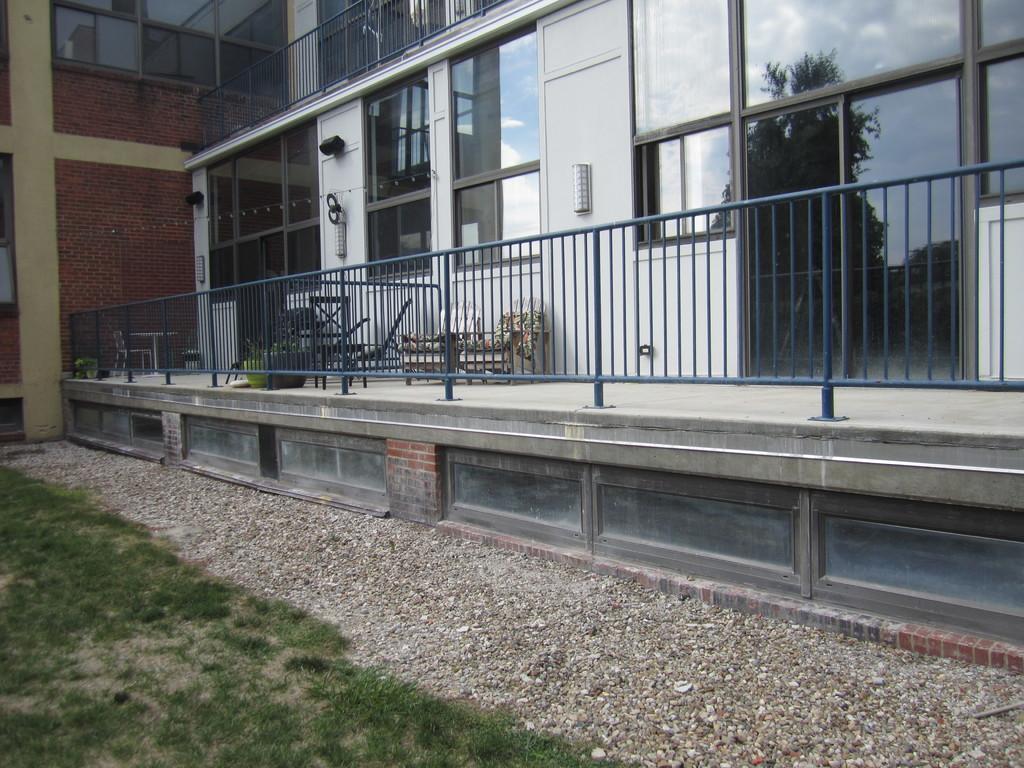How would you summarize this image in a sentence or two? There are small pebbles and grassland in the foreground area of the image, there is a building and chairs in the background. 